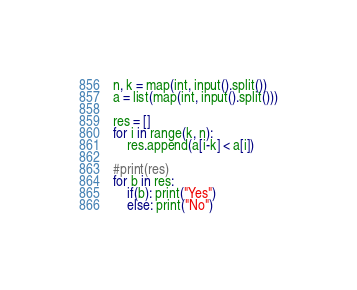Convert code to text. <code><loc_0><loc_0><loc_500><loc_500><_Python_>n, k = map(int, input().split())
a = list(map(int, input().split()))

res = []
for i in range(k, n):
    res.append(a[i-k] < a[i])

#print(res)
for b in res:
    if(b): print("Yes")
    else: print("No")</code> 